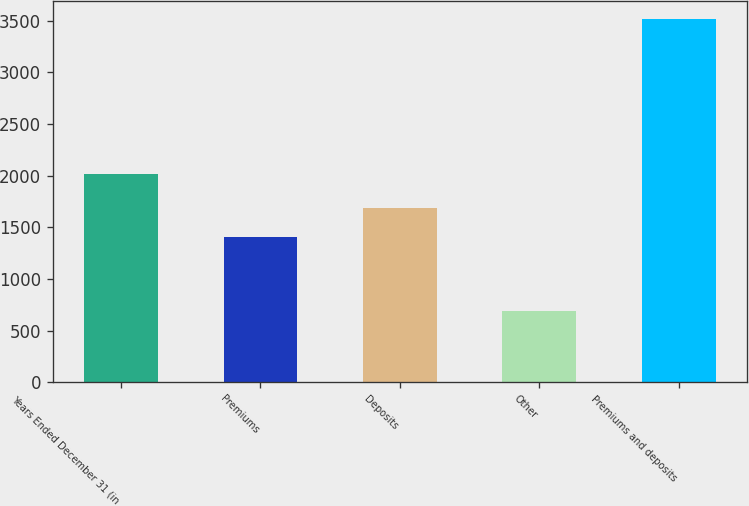Convert chart to OTSL. <chart><loc_0><loc_0><loc_500><loc_500><bar_chart><fcel>Years Ended December 31 (in<fcel>Premiums<fcel>Deposits<fcel>Other<fcel>Premiums and deposits<nl><fcel>2016<fcel>1407<fcel>1689.6<fcel>693<fcel>3519<nl></chart> 